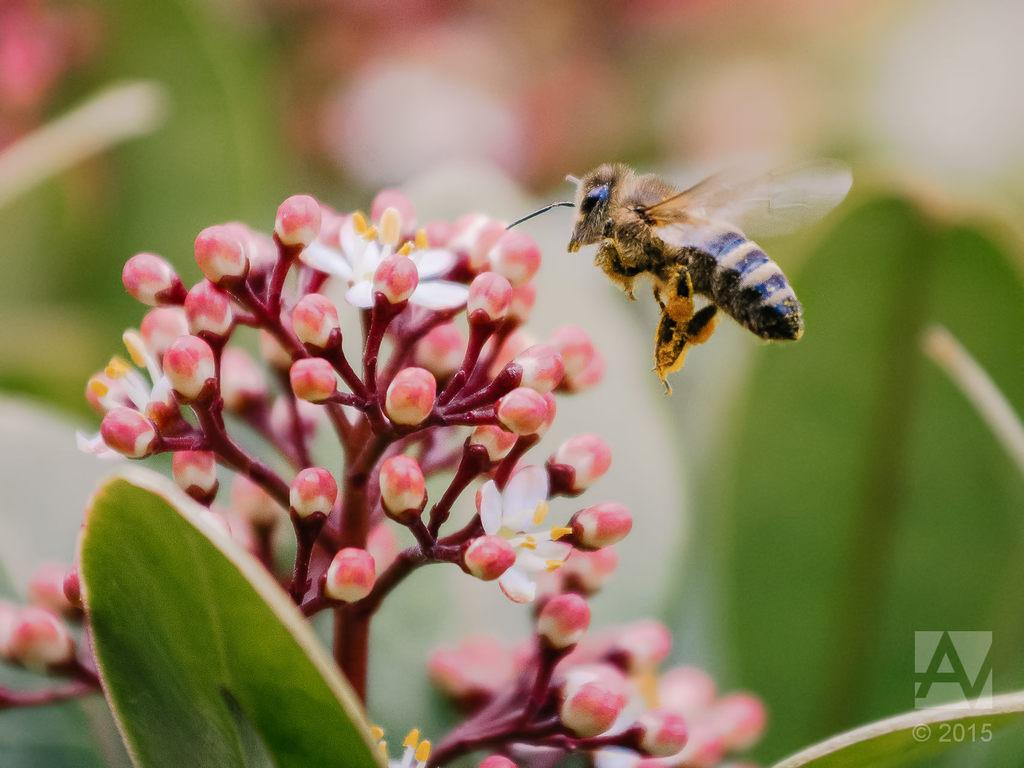What type of plant life is present in the image? There is a bunch of flower buds in the image. What insect can be seen in the image? A honey bee is flying in the image. What other natural element is visible in the image? There is a leaf in the image. Is there any indication of the image's origin or ownership? Yes, there is a watermark on the image. How many houses can be seen near the sea in the image? There are no houses or sea present in the image; it features a bunch of flower buds, a honey bee, a leaf, and a watermark. 